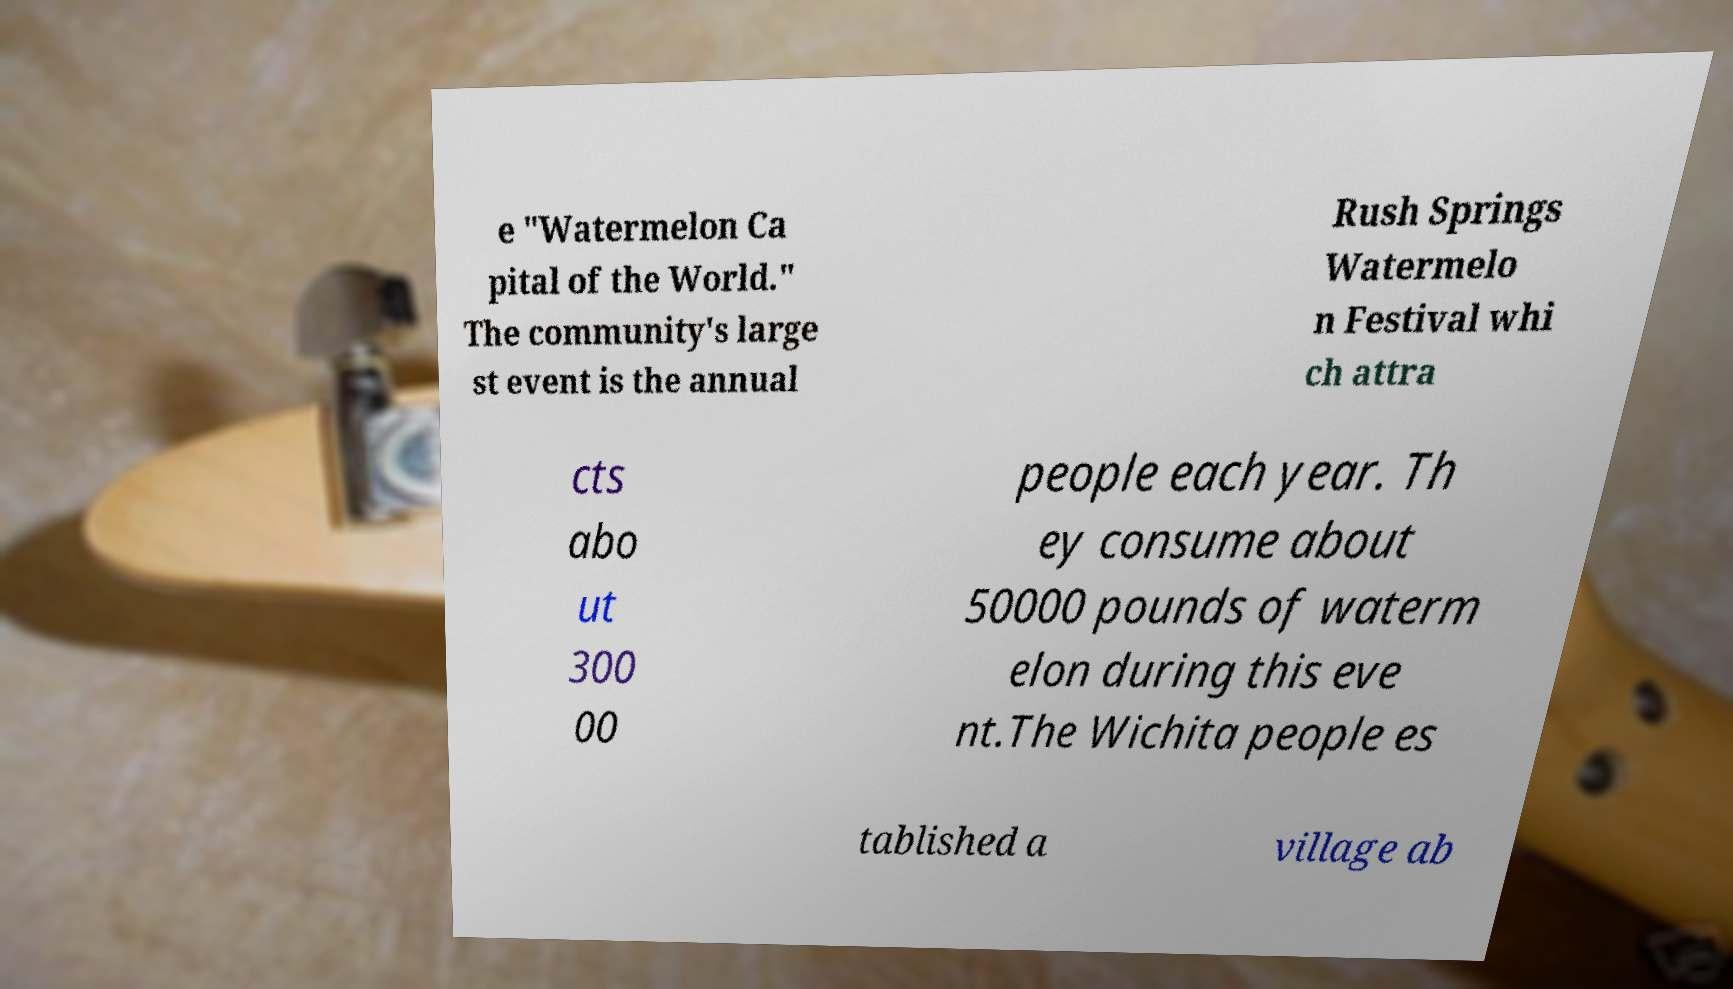There's text embedded in this image that I need extracted. Can you transcribe it verbatim? e "Watermelon Ca pital of the World." The community's large st event is the annual Rush Springs Watermelo n Festival whi ch attra cts abo ut 300 00 people each year. Th ey consume about 50000 pounds of waterm elon during this eve nt.The Wichita people es tablished a village ab 